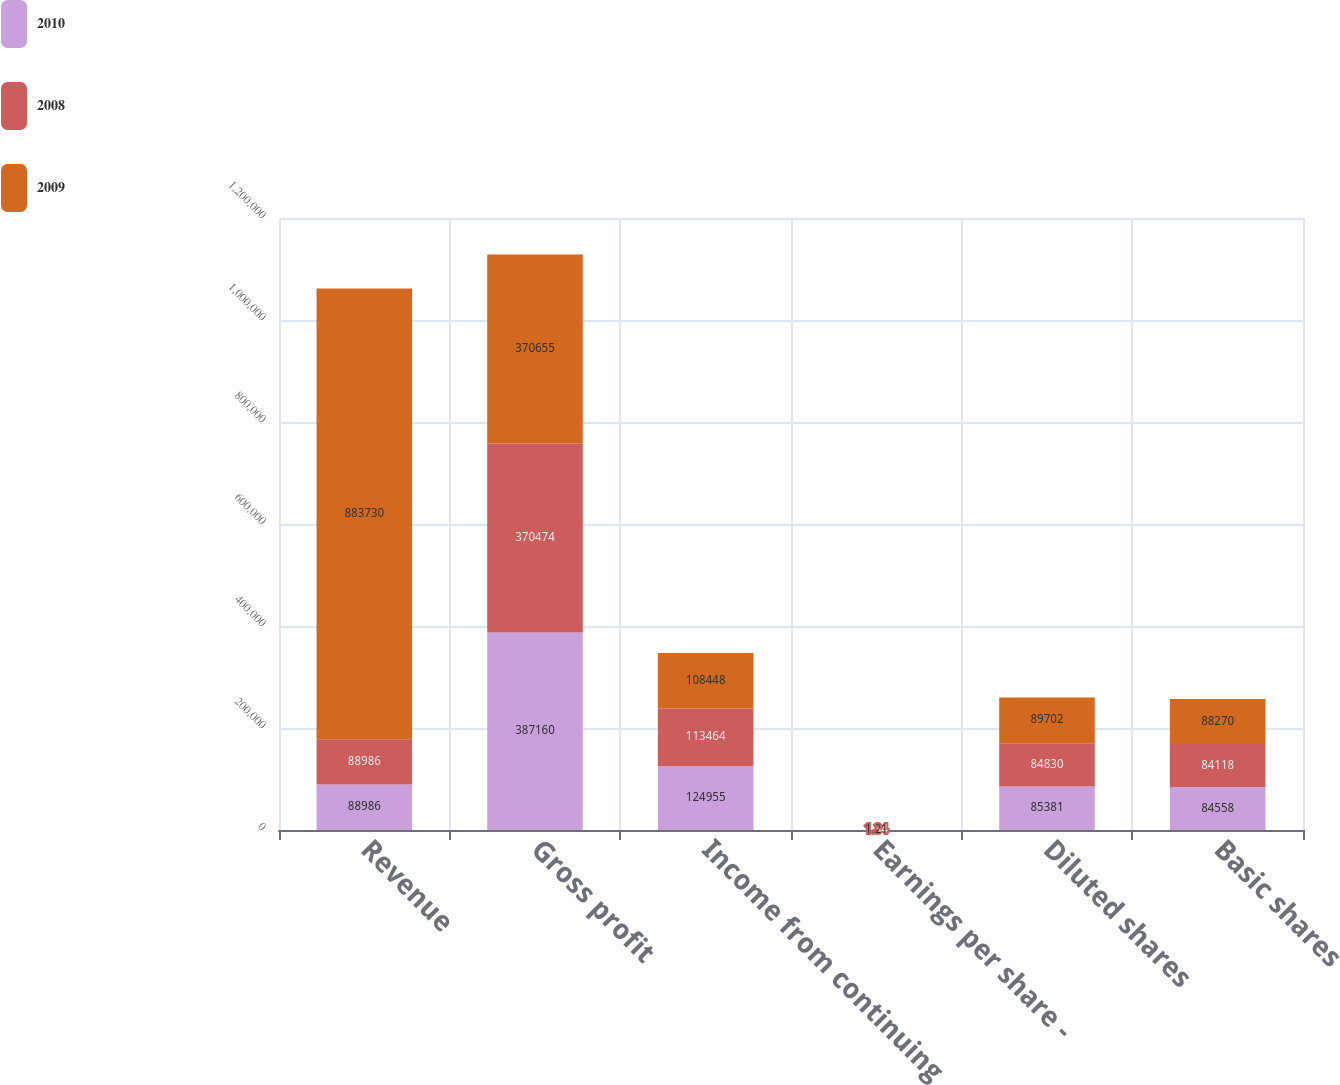Convert chart. <chart><loc_0><loc_0><loc_500><loc_500><stacked_bar_chart><ecel><fcel>Revenue<fcel>Gross profit<fcel>Income from continuing<fcel>Earnings per share -<fcel>Diluted shares<fcel>Basic shares<nl><fcel>2010<fcel>88986<fcel>387160<fcel>124955<fcel>1.46<fcel>85381<fcel>84558<nl><fcel>2008<fcel>88986<fcel>370474<fcel>113464<fcel>1.34<fcel>84830<fcel>84118<nl><fcel>2009<fcel>883730<fcel>370655<fcel>108448<fcel>1.21<fcel>89702<fcel>88270<nl></chart> 